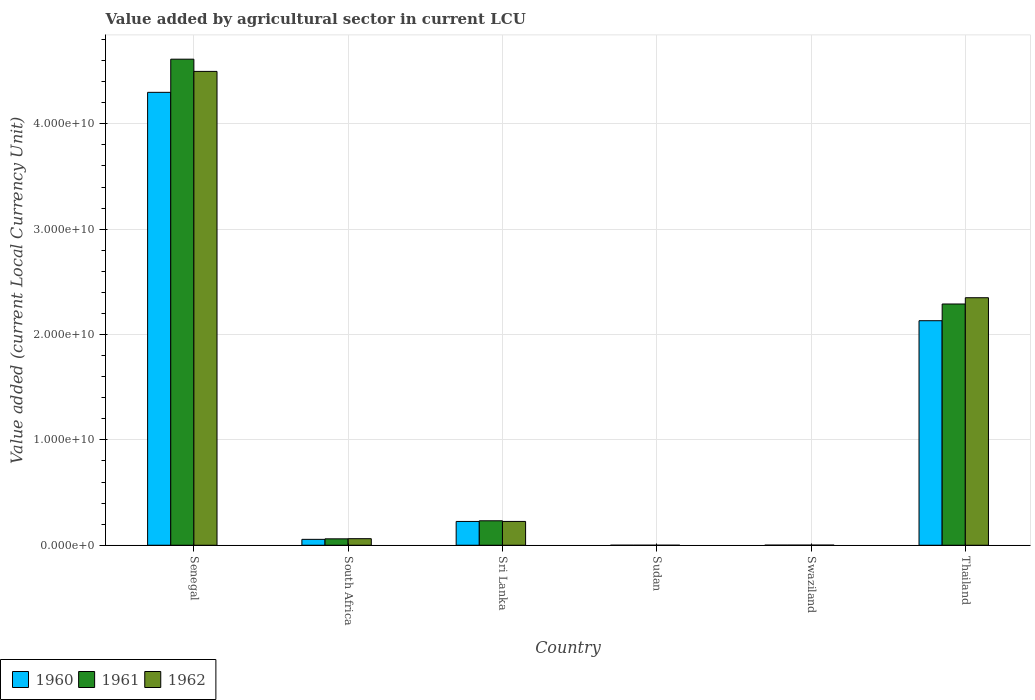How many groups of bars are there?
Your answer should be compact. 6. How many bars are there on the 2nd tick from the right?
Your answer should be compact. 3. What is the label of the 6th group of bars from the left?
Your answer should be very brief. Thailand. What is the value added by agricultural sector in 1961 in Sudan?
Offer a terse response. 2.19e+05. Across all countries, what is the maximum value added by agricultural sector in 1961?
Your answer should be compact. 4.61e+1. Across all countries, what is the minimum value added by agricultural sector in 1961?
Your response must be concise. 2.19e+05. In which country was the value added by agricultural sector in 1962 maximum?
Provide a succinct answer. Senegal. In which country was the value added by agricultural sector in 1960 minimum?
Offer a very short reply. Sudan. What is the total value added by agricultural sector in 1961 in the graph?
Your response must be concise. 7.20e+1. What is the difference between the value added by agricultural sector in 1962 in South Africa and that in Sudan?
Provide a succinct answer. 6.21e+08. What is the difference between the value added by agricultural sector in 1962 in Swaziland and the value added by agricultural sector in 1961 in Senegal?
Provide a succinct answer. -4.61e+1. What is the average value added by agricultural sector in 1962 per country?
Your answer should be compact. 1.19e+1. What is the difference between the value added by agricultural sector of/in 1960 and value added by agricultural sector of/in 1962 in Senegal?
Give a very brief answer. -1.99e+09. In how many countries, is the value added by agricultural sector in 1962 greater than 32000000000 LCU?
Offer a very short reply. 1. What is the ratio of the value added by agricultural sector in 1961 in Sudan to that in Thailand?
Keep it short and to the point. 9.577339642318114e-6. Is the difference between the value added by agricultural sector in 1960 in South Africa and Swaziland greater than the difference between the value added by agricultural sector in 1962 in South Africa and Swaziland?
Your answer should be very brief. No. What is the difference between the highest and the second highest value added by agricultural sector in 1960?
Make the answer very short. 4.07e+1. What is the difference between the highest and the lowest value added by agricultural sector in 1961?
Keep it short and to the point. 4.61e+1. In how many countries, is the value added by agricultural sector in 1962 greater than the average value added by agricultural sector in 1962 taken over all countries?
Offer a very short reply. 2. What does the 1st bar from the right in Swaziland represents?
Your response must be concise. 1962. Is it the case that in every country, the sum of the value added by agricultural sector in 1962 and value added by agricultural sector in 1961 is greater than the value added by agricultural sector in 1960?
Offer a terse response. Yes. How many bars are there?
Your response must be concise. 18. Are all the bars in the graph horizontal?
Your answer should be compact. No. What is the difference between two consecutive major ticks on the Y-axis?
Your response must be concise. 1.00e+1. Are the values on the major ticks of Y-axis written in scientific E-notation?
Make the answer very short. Yes. Where does the legend appear in the graph?
Provide a succinct answer. Bottom left. How are the legend labels stacked?
Provide a short and direct response. Horizontal. What is the title of the graph?
Make the answer very short. Value added by agricultural sector in current LCU. Does "2005" appear as one of the legend labels in the graph?
Ensure brevity in your answer.  No. What is the label or title of the Y-axis?
Make the answer very short. Value added (current Local Currency Unit). What is the Value added (current Local Currency Unit) of 1960 in Senegal?
Make the answer very short. 4.30e+1. What is the Value added (current Local Currency Unit) in 1961 in Senegal?
Make the answer very short. 4.61e+1. What is the Value added (current Local Currency Unit) in 1962 in Senegal?
Provide a short and direct response. 4.50e+1. What is the Value added (current Local Currency Unit) in 1960 in South Africa?
Keep it short and to the point. 5.59e+08. What is the Value added (current Local Currency Unit) of 1961 in South Africa?
Keep it short and to the point. 6.08e+08. What is the Value added (current Local Currency Unit) of 1962 in South Africa?
Your answer should be compact. 6.22e+08. What is the Value added (current Local Currency Unit) of 1960 in Sri Lanka?
Your answer should be very brief. 2.26e+09. What is the Value added (current Local Currency Unit) in 1961 in Sri Lanka?
Your answer should be very brief. 2.32e+09. What is the Value added (current Local Currency Unit) in 1962 in Sri Lanka?
Your response must be concise. 2.26e+09. What is the Value added (current Local Currency Unit) of 1960 in Sudan?
Ensure brevity in your answer.  2.02e+05. What is the Value added (current Local Currency Unit) of 1961 in Sudan?
Your answer should be very brief. 2.19e+05. What is the Value added (current Local Currency Unit) of 1962 in Sudan?
Ensure brevity in your answer.  2.31e+05. What is the Value added (current Local Currency Unit) in 1960 in Swaziland?
Provide a succinct answer. 7.90e+06. What is the Value added (current Local Currency Unit) in 1961 in Swaziland?
Your response must be concise. 9.30e+06. What is the Value added (current Local Currency Unit) of 1962 in Swaziland?
Provide a short and direct response. 1.14e+07. What is the Value added (current Local Currency Unit) in 1960 in Thailand?
Your response must be concise. 2.13e+1. What is the Value added (current Local Currency Unit) in 1961 in Thailand?
Keep it short and to the point. 2.29e+1. What is the Value added (current Local Currency Unit) of 1962 in Thailand?
Ensure brevity in your answer.  2.35e+1. Across all countries, what is the maximum Value added (current Local Currency Unit) of 1960?
Your response must be concise. 4.30e+1. Across all countries, what is the maximum Value added (current Local Currency Unit) of 1961?
Provide a succinct answer. 4.61e+1. Across all countries, what is the maximum Value added (current Local Currency Unit) of 1962?
Your answer should be very brief. 4.50e+1. Across all countries, what is the minimum Value added (current Local Currency Unit) in 1960?
Your answer should be very brief. 2.02e+05. Across all countries, what is the minimum Value added (current Local Currency Unit) in 1961?
Your answer should be very brief. 2.19e+05. Across all countries, what is the minimum Value added (current Local Currency Unit) of 1962?
Provide a short and direct response. 2.31e+05. What is the total Value added (current Local Currency Unit) of 1960 in the graph?
Your answer should be compact. 6.71e+1. What is the total Value added (current Local Currency Unit) of 1961 in the graph?
Offer a terse response. 7.20e+1. What is the total Value added (current Local Currency Unit) in 1962 in the graph?
Your answer should be compact. 7.14e+1. What is the difference between the Value added (current Local Currency Unit) in 1960 in Senegal and that in South Africa?
Provide a succinct answer. 4.24e+1. What is the difference between the Value added (current Local Currency Unit) in 1961 in Senegal and that in South Africa?
Provide a short and direct response. 4.55e+1. What is the difference between the Value added (current Local Currency Unit) of 1962 in Senegal and that in South Africa?
Provide a short and direct response. 4.44e+1. What is the difference between the Value added (current Local Currency Unit) in 1960 in Senegal and that in Sri Lanka?
Provide a short and direct response. 4.07e+1. What is the difference between the Value added (current Local Currency Unit) of 1961 in Senegal and that in Sri Lanka?
Provide a short and direct response. 4.38e+1. What is the difference between the Value added (current Local Currency Unit) in 1962 in Senegal and that in Sri Lanka?
Keep it short and to the point. 4.27e+1. What is the difference between the Value added (current Local Currency Unit) of 1960 in Senegal and that in Sudan?
Keep it short and to the point. 4.30e+1. What is the difference between the Value added (current Local Currency Unit) of 1961 in Senegal and that in Sudan?
Ensure brevity in your answer.  4.61e+1. What is the difference between the Value added (current Local Currency Unit) in 1962 in Senegal and that in Sudan?
Offer a very short reply. 4.50e+1. What is the difference between the Value added (current Local Currency Unit) of 1960 in Senegal and that in Swaziland?
Your answer should be compact. 4.30e+1. What is the difference between the Value added (current Local Currency Unit) of 1961 in Senegal and that in Swaziland?
Offer a very short reply. 4.61e+1. What is the difference between the Value added (current Local Currency Unit) in 1962 in Senegal and that in Swaziland?
Give a very brief answer. 4.50e+1. What is the difference between the Value added (current Local Currency Unit) in 1960 in Senegal and that in Thailand?
Offer a very short reply. 2.17e+1. What is the difference between the Value added (current Local Currency Unit) in 1961 in Senegal and that in Thailand?
Give a very brief answer. 2.32e+1. What is the difference between the Value added (current Local Currency Unit) in 1962 in Senegal and that in Thailand?
Ensure brevity in your answer.  2.15e+1. What is the difference between the Value added (current Local Currency Unit) of 1960 in South Africa and that in Sri Lanka?
Offer a terse response. -1.70e+09. What is the difference between the Value added (current Local Currency Unit) of 1961 in South Africa and that in Sri Lanka?
Keep it short and to the point. -1.71e+09. What is the difference between the Value added (current Local Currency Unit) of 1962 in South Africa and that in Sri Lanka?
Offer a terse response. -1.64e+09. What is the difference between the Value added (current Local Currency Unit) of 1960 in South Africa and that in Sudan?
Give a very brief answer. 5.59e+08. What is the difference between the Value added (current Local Currency Unit) in 1961 in South Africa and that in Sudan?
Your answer should be very brief. 6.07e+08. What is the difference between the Value added (current Local Currency Unit) in 1962 in South Africa and that in Sudan?
Provide a succinct answer. 6.21e+08. What is the difference between the Value added (current Local Currency Unit) in 1960 in South Africa and that in Swaziland?
Your response must be concise. 5.51e+08. What is the difference between the Value added (current Local Currency Unit) in 1961 in South Africa and that in Swaziland?
Ensure brevity in your answer.  5.98e+08. What is the difference between the Value added (current Local Currency Unit) of 1962 in South Africa and that in Swaziland?
Make the answer very short. 6.10e+08. What is the difference between the Value added (current Local Currency Unit) in 1960 in South Africa and that in Thailand?
Give a very brief answer. -2.08e+1. What is the difference between the Value added (current Local Currency Unit) of 1961 in South Africa and that in Thailand?
Your answer should be very brief. -2.23e+1. What is the difference between the Value added (current Local Currency Unit) in 1962 in South Africa and that in Thailand?
Your answer should be very brief. -2.29e+1. What is the difference between the Value added (current Local Currency Unit) of 1960 in Sri Lanka and that in Sudan?
Provide a short and direct response. 2.26e+09. What is the difference between the Value added (current Local Currency Unit) of 1961 in Sri Lanka and that in Sudan?
Your response must be concise. 2.32e+09. What is the difference between the Value added (current Local Currency Unit) of 1962 in Sri Lanka and that in Sudan?
Offer a terse response. 2.26e+09. What is the difference between the Value added (current Local Currency Unit) of 1960 in Sri Lanka and that in Swaziland?
Your answer should be very brief. 2.25e+09. What is the difference between the Value added (current Local Currency Unit) in 1961 in Sri Lanka and that in Swaziland?
Provide a short and direct response. 2.31e+09. What is the difference between the Value added (current Local Currency Unit) of 1962 in Sri Lanka and that in Swaziland?
Your response must be concise. 2.25e+09. What is the difference between the Value added (current Local Currency Unit) in 1960 in Sri Lanka and that in Thailand?
Your answer should be compact. -1.91e+1. What is the difference between the Value added (current Local Currency Unit) in 1961 in Sri Lanka and that in Thailand?
Your response must be concise. -2.06e+1. What is the difference between the Value added (current Local Currency Unit) of 1962 in Sri Lanka and that in Thailand?
Offer a very short reply. -2.12e+1. What is the difference between the Value added (current Local Currency Unit) in 1960 in Sudan and that in Swaziland?
Your answer should be compact. -7.70e+06. What is the difference between the Value added (current Local Currency Unit) in 1961 in Sudan and that in Swaziland?
Offer a terse response. -9.08e+06. What is the difference between the Value added (current Local Currency Unit) of 1962 in Sudan and that in Swaziland?
Ensure brevity in your answer.  -1.12e+07. What is the difference between the Value added (current Local Currency Unit) in 1960 in Sudan and that in Thailand?
Provide a succinct answer. -2.13e+1. What is the difference between the Value added (current Local Currency Unit) in 1961 in Sudan and that in Thailand?
Offer a very short reply. -2.29e+1. What is the difference between the Value added (current Local Currency Unit) in 1962 in Sudan and that in Thailand?
Your answer should be very brief. -2.35e+1. What is the difference between the Value added (current Local Currency Unit) in 1960 in Swaziland and that in Thailand?
Keep it short and to the point. -2.13e+1. What is the difference between the Value added (current Local Currency Unit) in 1961 in Swaziland and that in Thailand?
Ensure brevity in your answer.  -2.29e+1. What is the difference between the Value added (current Local Currency Unit) of 1962 in Swaziland and that in Thailand?
Make the answer very short. -2.35e+1. What is the difference between the Value added (current Local Currency Unit) in 1960 in Senegal and the Value added (current Local Currency Unit) in 1961 in South Africa?
Keep it short and to the point. 4.24e+1. What is the difference between the Value added (current Local Currency Unit) in 1960 in Senegal and the Value added (current Local Currency Unit) in 1962 in South Africa?
Offer a terse response. 4.24e+1. What is the difference between the Value added (current Local Currency Unit) of 1961 in Senegal and the Value added (current Local Currency Unit) of 1962 in South Africa?
Provide a short and direct response. 4.55e+1. What is the difference between the Value added (current Local Currency Unit) of 1960 in Senegal and the Value added (current Local Currency Unit) of 1961 in Sri Lanka?
Your answer should be very brief. 4.07e+1. What is the difference between the Value added (current Local Currency Unit) in 1960 in Senegal and the Value added (current Local Currency Unit) in 1962 in Sri Lanka?
Your answer should be very brief. 4.07e+1. What is the difference between the Value added (current Local Currency Unit) in 1961 in Senegal and the Value added (current Local Currency Unit) in 1962 in Sri Lanka?
Provide a succinct answer. 4.39e+1. What is the difference between the Value added (current Local Currency Unit) of 1960 in Senegal and the Value added (current Local Currency Unit) of 1961 in Sudan?
Keep it short and to the point. 4.30e+1. What is the difference between the Value added (current Local Currency Unit) in 1960 in Senegal and the Value added (current Local Currency Unit) in 1962 in Sudan?
Your answer should be very brief. 4.30e+1. What is the difference between the Value added (current Local Currency Unit) of 1961 in Senegal and the Value added (current Local Currency Unit) of 1962 in Sudan?
Provide a short and direct response. 4.61e+1. What is the difference between the Value added (current Local Currency Unit) in 1960 in Senegal and the Value added (current Local Currency Unit) in 1961 in Swaziland?
Offer a terse response. 4.30e+1. What is the difference between the Value added (current Local Currency Unit) in 1960 in Senegal and the Value added (current Local Currency Unit) in 1962 in Swaziland?
Ensure brevity in your answer.  4.30e+1. What is the difference between the Value added (current Local Currency Unit) in 1961 in Senegal and the Value added (current Local Currency Unit) in 1962 in Swaziland?
Provide a succinct answer. 4.61e+1. What is the difference between the Value added (current Local Currency Unit) of 1960 in Senegal and the Value added (current Local Currency Unit) of 1961 in Thailand?
Provide a succinct answer. 2.01e+1. What is the difference between the Value added (current Local Currency Unit) of 1960 in Senegal and the Value added (current Local Currency Unit) of 1962 in Thailand?
Offer a terse response. 1.95e+1. What is the difference between the Value added (current Local Currency Unit) in 1961 in Senegal and the Value added (current Local Currency Unit) in 1962 in Thailand?
Your answer should be compact. 2.26e+1. What is the difference between the Value added (current Local Currency Unit) of 1960 in South Africa and the Value added (current Local Currency Unit) of 1961 in Sri Lanka?
Make the answer very short. -1.76e+09. What is the difference between the Value added (current Local Currency Unit) in 1960 in South Africa and the Value added (current Local Currency Unit) in 1962 in Sri Lanka?
Offer a terse response. -1.70e+09. What is the difference between the Value added (current Local Currency Unit) in 1961 in South Africa and the Value added (current Local Currency Unit) in 1962 in Sri Lanka?
Offer a very short reply. -1.65e+09. What is the difference between the Value added (current Local Currency Unit) of 1960 in South Africa and the Value added (current Local Currency Unit) of 1961 in Sudan?
Your answer should be very brief. 5.59e+08. What is the difference between the Value added (current Local Currency Unit) of 1960 in South Africa and the Value added (current Local Currency Unit) of 1962 in Sudan?
Make the answer very short. 5.59e+08. What is the difference between the Value added (current Local Currency Unit) of 1961 in South Africa and the Value added (current Local Currency Unit) of 1962 in Sudan?
Provide a short and direct response. 6.07e+08. What is the difference between the Value added (current Local Currency Unit) in 1960 in South Africa and the Value added (current Local Currency Unit) in 1961 in Swaziland?
Ensure brevity in your answer.  5.50e+08. What is the difference between the Value added (current Local Currency Unit) in 1960 in South Africa and the Value added (current Local Currency Unit) in 1962 in Swaziland?
Keep it short and to the point. 5.48e+08. What is the difference between the Value added (current Local Currency Unit) of 1961 in South Africa and the Value added (current Local Currency Unit) of 1962 in Swaziland?
Your answer should be compact. 5.96e+08. What is the difference between the Value added (current Local Currency Unit) in 1960 in South Africa and the Value added (current Local Currency Unit) in 1961 in Thailand?
Provide a short and direct response. -2.23e+1. What is the difference between the Value added (current Local Currency Unit) of 1960 in South Africa and the Value added (current Local Currency Unit) of 1962 in Thailand?
Offer a very short reply. -2.29e+1. What is the difference between the Value added (current Local Currency Unit) in 1961 in South Africa and the Value added (current Local Currency Unit) in 1962 in Thailand?
Provide a short and direct response. -2.29e+1. What is the difference between the Value added (current Local Currency Unit) in 1960 in Sri Lanka and the Value added (current Local Currency Unit) in 1961 in Sudan?
Your answer should be very brief. 2.26e+09. What is the difference between the Value added (current Local Currency Unit) in 1960 in Sri Lanka and the Value added (current Local Currency Unit) in 1962 in Sudan?
Give a very brief answer. 2.26e+09. What is the difference between the Value added (current Local Currency Unit) in 1961 in Sri Lanka and the Value added (current Local Currency Unit) in 1962 in Sudan?
Provide a succinct answer. 2.32e+09. What is the difference between the Value added (current Local Currency Unit) of 1960 in Sri Lanka and the Value added (current Local Currency Unit) of 1961 in Swaziland?
Keep it short and to the point. 2.25e+09. What is the difference between the Value added (current Local Currency Unit) in 1960 in Sri Lanka and the Value added (current Local Currency Unit) in 1962 in Swaziland?
Give a very brief answer. 2.25e+09. What is the difference between the Value added (current Local Currency Unit) of 1961 in Sri Lanka and the Value added (current Local Currency Unit) of 1962 in Swaziland?
Offer a very short reply. 2.31e+09. What is the difference between the Value added (current Local Currency Unit) in 1960 in Sri Lanka and the Value added (current Local Currency Unit) in 1961 in Thailand?
Provide a short and direct response. -2.06e+1. What is the difference between the Value added (current Local Currency Unit) of 1960 in Sri Lanka and the Value added (current Local Currency Unit) of 1962 in Thailand?
Your answer should be compact. -2.12e+1. What is the difference between the Value added (current Local Currency Unit) in 1961 in Sri Lanka and the Value added (current Local Currency Unit) in 1962 in Thailand?
Offer a terse response. -2.12e+1. What is the difference between the Value added (current Local Currency Unit) in 1960 in Sudan and the Value added (current Local Currency Unit) in 1961 in Swaziland?
Provide a succinct answer. -9.10e+06. What is the difference between the Value added (current Local Currency Unit) of 1960 in Sudan and the Value added (current Local Currency Unit) of 1962 in Swaziland?
Make the answer very short. -1.12e+07. What is the difference between the Value added (current Local Currency Unit) of 1961 in Sudan and the Value added (current Local Currency Unit) of 1962 in Swaziland?
Your answer should be very brief. -1.12e+07. What is the difference between the Value added (current Local Currency Unit) of 1960 in Sudan and the Value added (current Local Currency Unit) of 1961 in Thailand?
Keep it short and to the point. -2.29e+1. What is the difference between the Value added (current Local Currency Unit) in 1960 in Sudan and the Value added (current Local Currency Unit) in 1962 in Thailand?
Offer a terse response. -2.35e+1. What is the difference between the Value added (current Local Currency Unit) of 1961 in Sudan and the Value added (current Local Currency Unit) of 1962 in Thailand?
Your response must be concise. -2.35e+1. What is the difference between the Value added (current Local Currency Unit) of 1960 in Swaziland and the Value added (current Local Currency Unit) of 1961 in Thailand?
Provide a succinct answer. -2.29e+1. What is the difference between the Value added (current Local Currency Unit) in 1960 in Swaziland and the Value added (current Local Currency Unit) in 1962 in Thailand?
Offer a terse response. -2.35e+1. What is the difference between the Value added (current Local Currency Unit) of 1961 in Swaziland and the Value added (current Local Currency Unit) of 1962 in Thailand?
Give a very brief answer. -2.35e+1. What is the average Value added (current Local Currency Unit) in 1960 per country?
Give a very brief answer. 1.12e+1. What is the average Value added (current Local Currency Unit) of 1961 per country?
Give a very brief answer. 1.20e+1. What is the average Value added (current Local Currency Unit) of 1962 per country?
Keep it short and to the point. 1.19e+1. What is the difference between the Value added (current Local Currency Unit) of 1960 and Value added (current Local Currency Unit) of 1961 in Senegal?
Your response must be concise. -3.15e+09. What is the difference between the Value added (current Local Currency Unit) of 1960 and Value added (current Local Currency Unit) of 1962 in Senegal?
Your response must be concise. -1.99e+09. What is the difference between the Value added (current Local Currency Unit) of 1961 and Value added (current Local Currency Unit) of 1962 in Senegal?
Make the answer very short. 1.16e+09. What is the difference between the Value added (current Local Currency Unit) in 1960 and Value added (current Local Currency Unit) in 1961 in South Africa?
Your answer should be compact. -4.85e+07. What is the difference between the Value added (current Local Currency Unit) of 1960 and Value added (current Local Currency Unit) of 1962 in South Africa?
Make the answer very short. -6.25e+07. What is the difference between the Value added (current Local Currency Unit) of 1961 and Value added (current Local Currency Unit) of 1962 in South Africa?
Your answer should be very brief. -1.40e+07. What is the difference between the Value added (current Local Currency Unit) in 1960 and Value added (current Local Currency Unit) in 1961 in Sri Lanka?
Ensure brevity in your answer.  -6.20e+07. What is the difference between the Value added (current Local Currency Unit) in 1961 and Value added (current Local Currency Unit) in 1962 in Sri Lanka?
Provide a short and direct response. 6.10e+07. What is the difference between the Value added (current Local Currency Unit) in 1960 and Value added (current Local Currency Unit) in 1961 in Sudan?
Give a very brief answer. -1.76e+04. What is the difference between the Value added (current Local Currency Unit) in 1960 and Value added (current Local Currency Unit) in 1962 in Sudan?
Offer a very short reply. -2.90e+04. What is the difference between the Value added (current Local Currency Unit) of 1961 and Value added (current Local Currency Unit) of 1962 in Sudan?
Ensure brevity in your answer.  -1.14e+04. What is the difference between the Value added (current Local Currency Unit) of 1960 and Value added (current Local Currency Unit) of 1961 in Swaziland?
Your answer should be very brief. -1.40e+06. What is the difference between the Value added (current Local Currency Unit) of 1960 and Value added (current Local Currency Unit) of 1962 in Swaziland?
Your response must be concise. -3.50e+06. What is the difference between the Value added (current Local Currency Unit) in 1961 and Value added (current Local Currency Unit) in 1962 in Swaziland?
Make the answer very short. -2.10e+06. What is the difference between the Value added (current Local Currency Unit) in 1960 and Value added (current Local Currency Unit) in 1961 in Thailand?
Your answer should be very brief. -1.59e+09. What is the difference between the Value added (current Local Currency Unit) in 1960 and Value added (current Local Currency Unit) in 1962 in Thailand?
Keep it short and to the point. -2.18e+09. What is the difference between the Value added (current Local Currency Unit) in 1961 and Value added (current Local Currency Unit) in 1962 in Thailand?
Provide a short and direct response. -5.95e+08. What is the ratio of the Value added (current Local Currency Unit) in 1960 in Senegal to that in South Africa?
Keep it short and to the point. 76.89. What is the ratio of the Value added (current Local Currency Unit) in 1961 in Senegal to that in South Africa?
Offer a terse response. 75.92. What is the ratio of the Value added (current Local Currency Unit) of 1962 in Senegal to that in South Africa?
Make the answer very short. 72.35. What is the ratio of the Value added (current Local Currency Unit) of 1960 in Senegal to that in Sri Lanka?
Provide a succinct answer. 19.04. What is the ratio of the Value added (current Local Currency Unit) in 1961 in Senegal to that in Sri Lanka?
Your answer should be compact. 19.89. What is the ratio of the Value added (current Local Currency Unit) of 1962 in Senegal to that in Sri Lanka?
Make the answer very short. 19.91. What is the ratio of the Value added (current Local Currency Unit) of 1960 in Senegal to that in Sudan?
Offer a terse response. 2.13e+05. What is the ratio of the Value added (current Local Currency Unit) in 1961 in Senegal to that in Sudan?
Keep it short and to the point. 2.10e+05. What is the ratio of the Value added (current Local Currency Unit) in 1962 in Senegal to that in Sudan?
Offer a very short reply. 1.95e+05. What is the ratio of the Value added (current Local Currency Unit) of 1960 in Senegal to that in Swaziland?
Make the answer very short. 5441.53. What is the ratio of the Value added (current Local Currency Unit) in 1961 in Senegal to that in Swaziland?
Your answer should be compact. 4960.82. What is the ratio of the Value added (current Local Currency Unit) of 1962 in Senegal to that in Swaziland?
Offer a terse response. 3945.26. What is the ratio of the Value added (current Local Currency Unit) in 1960 in Senegal to that in Thailand?
Your answer should be compact. 2.02. What is the ratio of the Value added (current Local Currency Unit) of 1961 in Senegal to that in Thailand?
Your answer should be very brief. 2.01. What is the ratio of the Value added (current Local Currency Unit) of 1962 in Senegal to that in Thailand?
Provide a succinct answer. 1.91. What is the ratio of the Value added (current Local Currency Unit) of 1960 in South Africa to that in Sri Lanka?
Offer a very short reply. 0.25. What is the ratio of the Value added (current Local Currency Unit) of 1961 in South Africa to that in Sri Lanka?
Your response must be concise. 0.26. What is the ratio of the Value added (current Local Currency Unit) of 1962 in South Africa to that in Sri Lanka?
Ensure brevity in your answer.  0.28. What is the ratio of the Value added (current Local Currency Unit) of 1960 in South Africa to that in Sudan?
Give a very brief answer. 2772.04. What is the ratio of the Value added (current Local Currency Unit) in 1961 in South Africa to that in Sudan?
Provide a succinct answer. 2770.9. What is the ratio of the Value added (current Local Currency Unit) of 1962 in South Africa to that in Sudan?
Your answer should be very brief. 2694.67. What is the ratio of the Value added (current Local Currency Unit) of 1960 in South Africa to that in Swaziland?
Keep it short and to the point. 70.77. What is the ratio of the Value added (current Local Currency Unit) in 1961 in South Africa to that in Swaziland?
Your answer should be compact. 65.34. What is the ratio of the Value added (current Local Currency Unit) of 1962 in South Africa to that in Swaziland?
Your answer should be compact. 54.53. What is the ratio of the Value added (current Local Currency Unit) in 1960 in South Africa to that in Thailand?
Your response must be concise. 0.03. What is the ratio of the Value added (current Local Currency Unit) of 1961 in South Africa to that in Thailand?
Give a very brief answer. 0.03. What is the ratio of the Value added (current Local Currency Unit) of 1962 in South Africa to that in Thailand?
Provide a short and direct response. 0.03. What is the ratio of the Value added (current Local Currency Unit) of 1960 in Sri Lanka to that in Sudan?
Give a very brief answer. 1.12e+04. What is the ratio of the Value added (current Local Currency Unit) in 1961 in Sri Lanka to that in Sudan?
Provide a short and direct response. 1.06e+04. What is the ratio of the Value added (current Local Currency Unit) in 1962 in Sri Lanka to that in Sudan?
Your answer should be compact. 9791.94. What is the ratio of the Value added (current Local Currency Unit) in 1960 in Sri Lanka to that in Swaziland?
Ensure brevity in your answer.  285.82. What is the ratio of the Value added (current Local Currency Unit) in 1961 in Sri Lanka to that in Swaziland?
Offer a very short reply. 249.46. What is the ratio of the Value added (current Local Currency Unit) in 1962 in Sri Lanka to that in Swaziland?
Give a very brief answer. 198.16. What is the ratio of the Value added (current Local Currency Unit) of 1960 in Sri Lanka to that in Thailand?
Offer a terse response. 0.11. What is the ratio of the Value added (current Local Currency Unit) of 1961 in Sri Lanka to that in Thailand?
Offer a very short reply. 0.1. What is the ratio of the Value added (current Local Currency Unit) of 1962 in Sri Lanka to that in Thailand?
Offer a terse response. 0.1. What is the ratio of the Value added (current Local Currency Unit) of 1960 in Sudan to that in Swaziland?
Your answer should be very brief. 0.03. What is the ratio of the Value added (current Local Currency Unit) of 1961 in Sudan to that in Swaziland?
Make the answer very short. 0.02. What is the ratio of the Value added (current Local Currency Unit) in 1962 in Sudan to that in Swaziland?
Provide a short and direct response. 0.02. What is the ratio of the Value added (current Local Currency Unit) in 1961 in Sudan to that in Thailand?
Provide a succinct answer. 0. What is the ratio of the Value added (current Local Currency Unit) in 1962 in Sudan to that in Thailand?
Make the answer very short. 0. What is the ratio of the Value added (current Local Currency Unit) in 1960 in Swaziland to that in Thailand?
Offer a terse response. 0. What is the ratio of the Value added (current Local Currency Unit) in 1961 in Swaziland to that in Thailand?
Your answer should be compact. 0. What is the difference between the highest and the second highest Value added (current Local Currency Unit) in 1960?
Your answer should be very brief. 2.17e+1. What is the difference between the highest and the second highest Value added (current Local Currency Unit) in 1961?
Provide a short and direct response. 2.32e+1. What is the difference between the highest and the second highest Value added (current Local Currency Unit) in 1962?
Your response must be concise. 2.15e+1. What is the difference between the highest and the lowest Value added (current Local Currency Unit) of 1960?
Your response must be concise. 4.30e+1. What is the difference between the highest and the lowest Value added (current Local Currency Unit) in 1961?
Ensure brevity in your answer.  4.61e+1. What is the difference between the highest and the lowest Value added (current Local Currency Unit) in 1962?
Your answer should be very brief. 4.50e+1. 